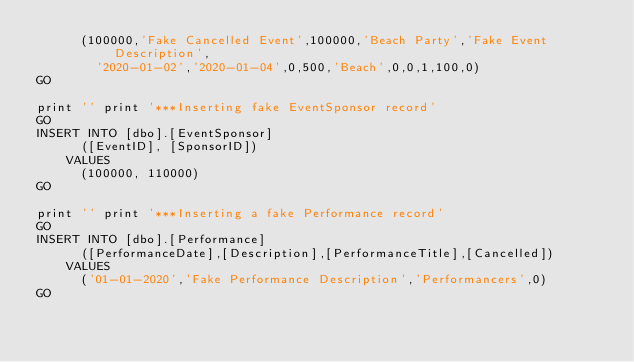<code> <loc_0><loc_0><loc_500><loc_500><_SQL_>			(100000,'Fake Cancelled Event',100000,'Beach Party','Fake Event Description',
				'2020-01-02','2020-01-04',0,500,'Beach',0,0,1,100,0)
GO	

print '' print '***Inserting fake EventSponsor record'
GO
INSERT INTO [dbo].[EventSponsor]
			([EventID], [SponsorID])
		VALUES
			(100000, 110000)
GO

print '' print '***Inserting a fake Performance record'
GO
INSERT INTO [dbo].[Performance]
			([PerformanceDate],[Description],[PerformanceTitle],[Cancelled])
		VALUES
			('01-01-2020','Fake Performance Description','Performancers',0)
GO

</code> 